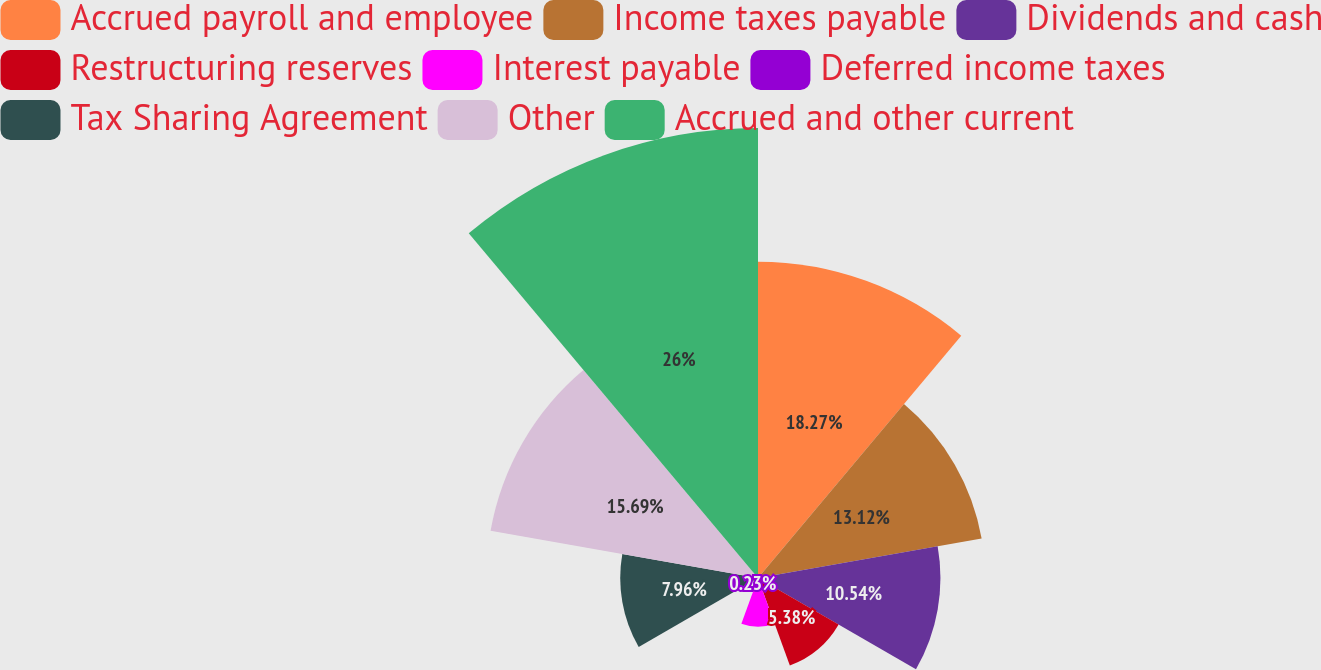Convert chart. <chart><loc_0><loc_0><loc_500><loc_500><pie_chart><fcel>Accrued payroll and employee<fcel>Income taxes payable<fcel>Dividends and cash<fcel>Restructuring reserves<fcel>Interest payable<fcel>Deferred income taxes<fcel>Tax Sharing Agreement<fcel>Other<fcel>Accrued and other current<nl><fcel>18.27%<fcel>13.12%<fcel>10.54%<fcel>5.38%<fcel>2.81%<fcel>0.23%<fcel>7.96%<fcel>15.69%<fcel>26.0%<nl></chart> 